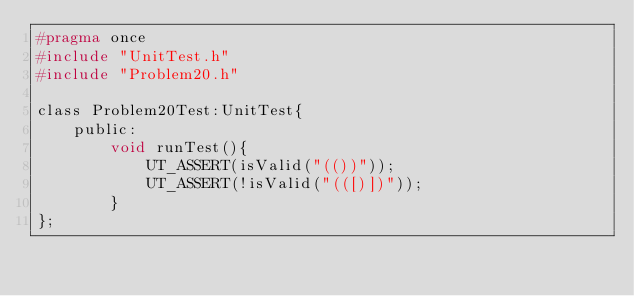Convert code to text. <code><loc_0><loc_0><loc_500><loc_500><_C_>#pragma once
#include "UnitTest.h"
#include "Problem20.h"

class Problem20Test:UnitTest{
    public:
        void runTest(){
            UT_ASSERT(isValid("(())"));
            UT_ASSERT(!isValid("(([)])"));
        }
};</code> 